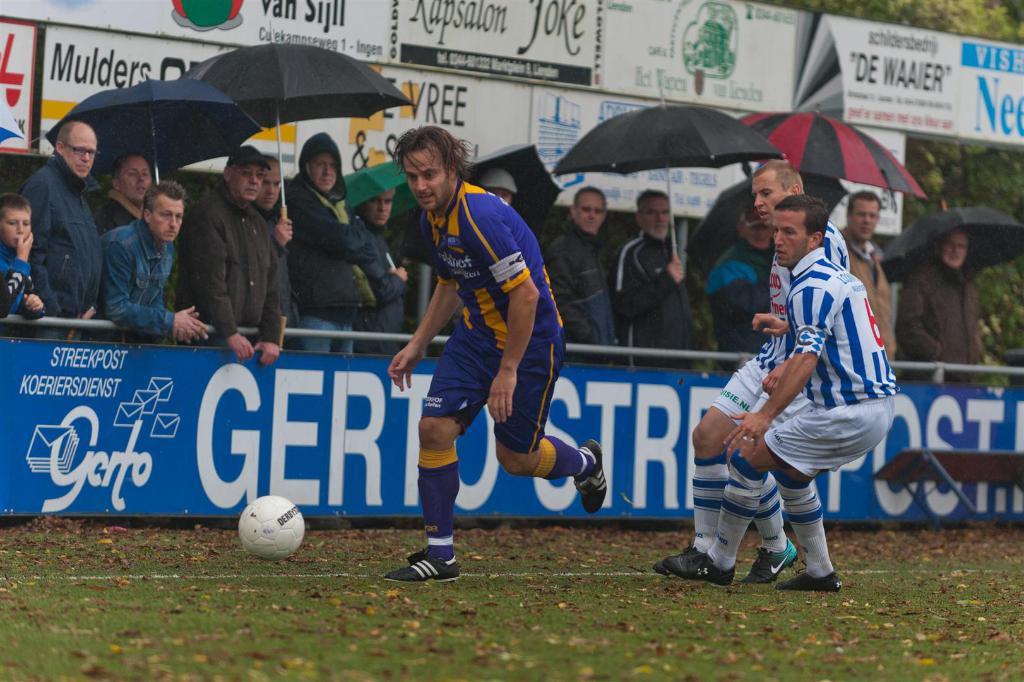Who is the advertiser that begins with an m above the two umbrellas?
Provide a succinct answer. Mulders. What sponsor begins with a g?
Offer a very short reply. Gerto. 